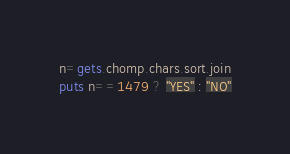Convert code to text. <code><loc_0><loc_0><loc_500><loc_500><_Ruby_>n=gets.chomp.chars.sort.join
puts n==1479 ? "YES" : "NO"</code> 